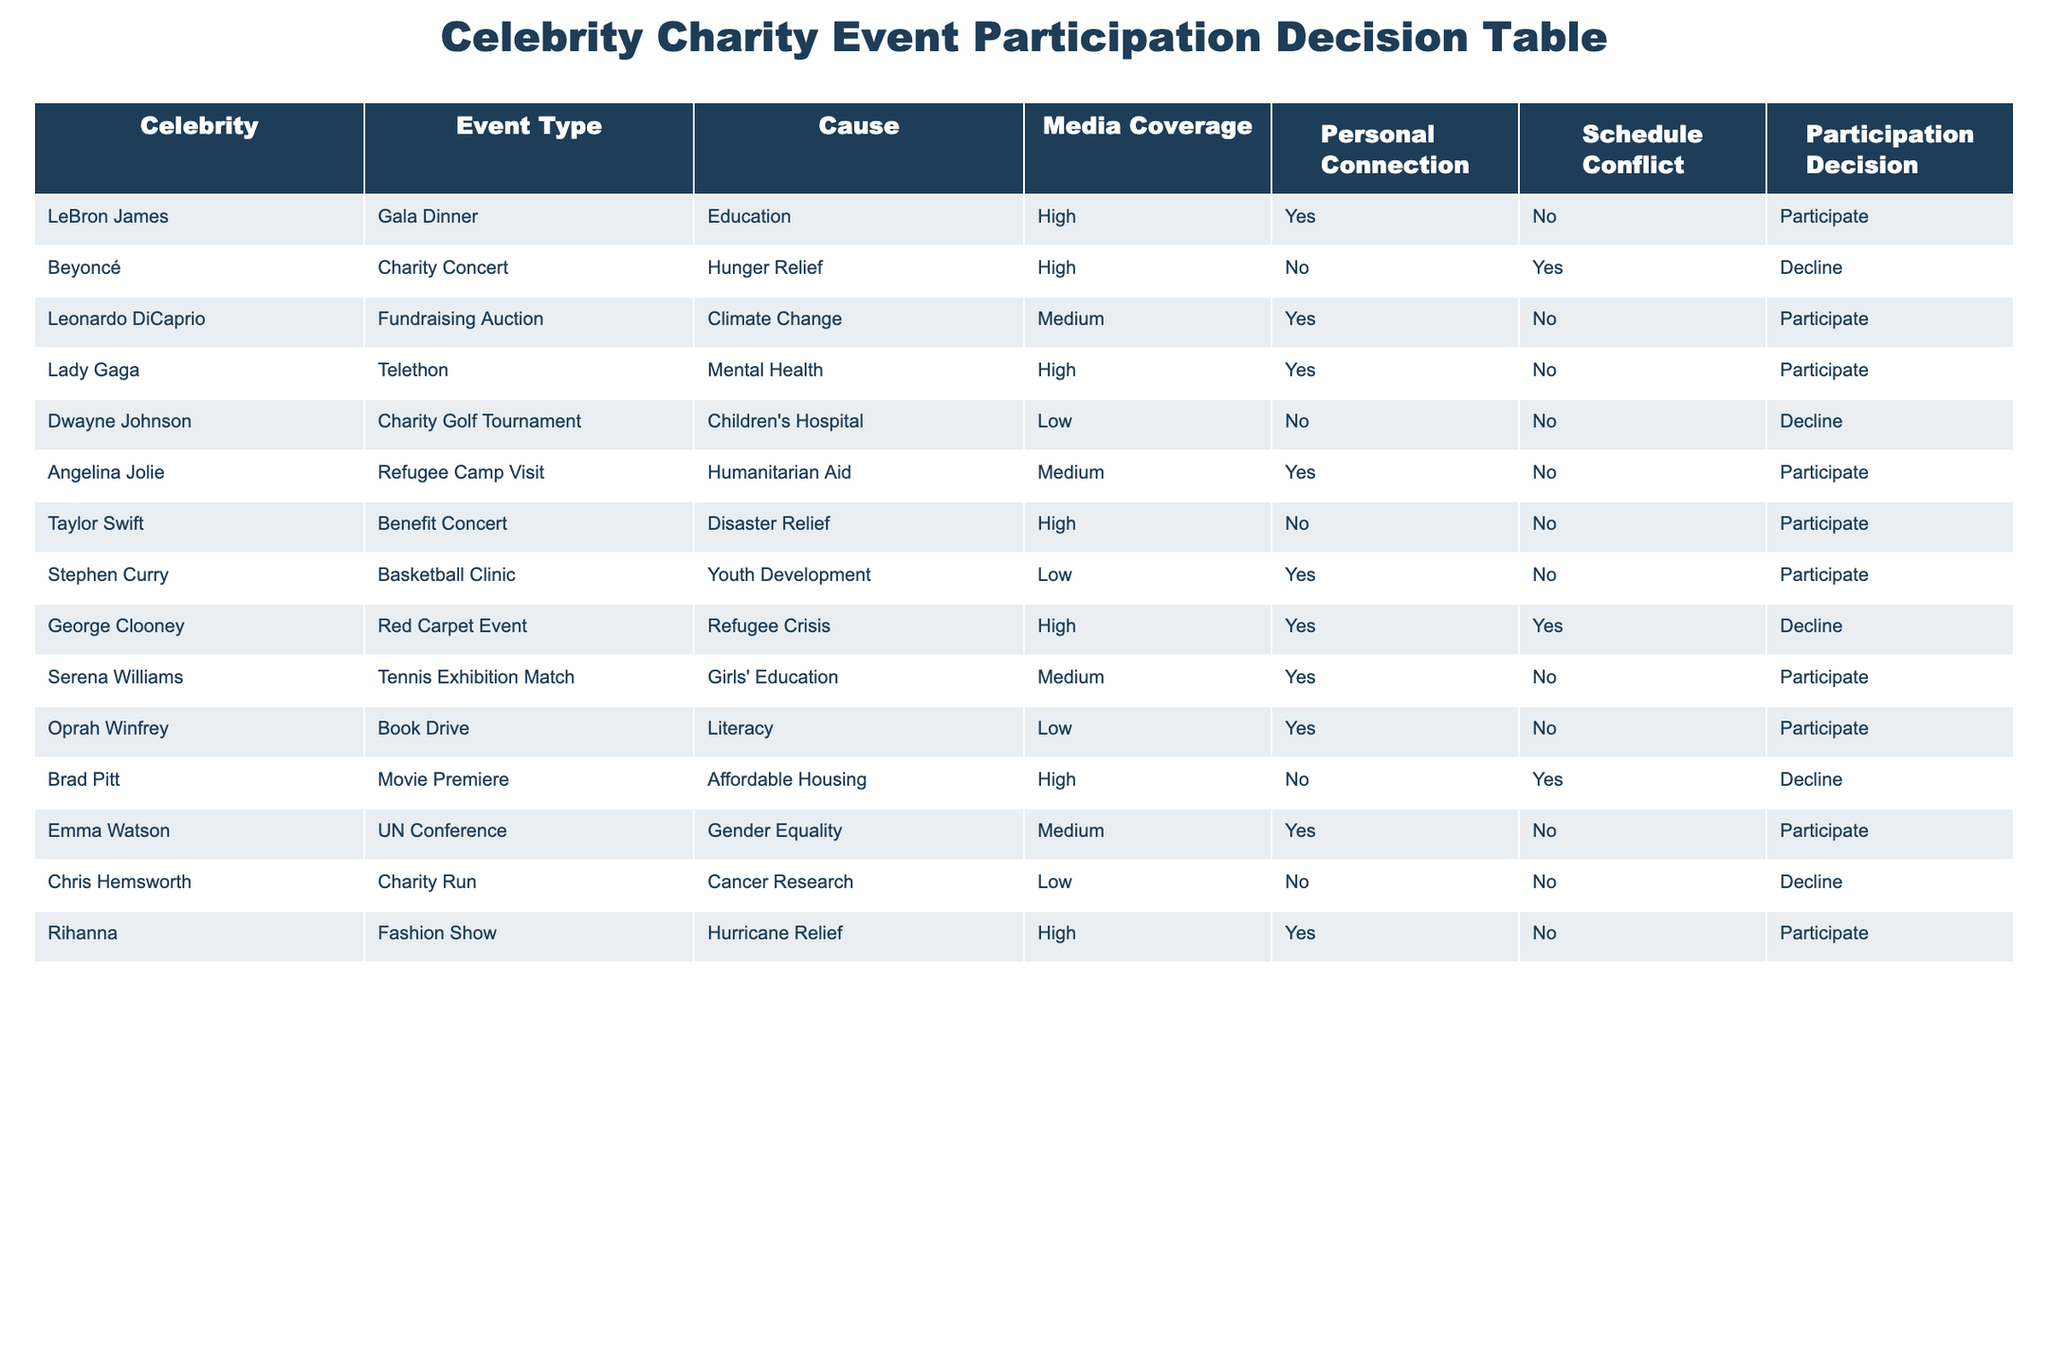What is the participation decision for Leonardo DiCaprio? In the table, we can locate the row for Leonardo DiCaprio, where his participation decision is stated clearly. Based on this information, his decision is to participate in the fundraising auction for climate change.
Answer: Participate How many celebrities declined to participate in an event? By scanning the table for the participation decision, I can count the rows where the decision is "Decline." There are four celebrities who declined to participate: Beyoncé, Dwayne Johnson, George Clooney, and Brad Pitt.
Answer: 4 Which celebrity has a personal connection to their cause but decided not to participate? I can look for rows where "Personal Connection" is marked as "Yes" and "Participation Decision" as "Decline." The only celebrity fitting this description is George Clooney, who has a personal connection to the refugee crisis but declined to participate in the red carpet event.
Answer: George Clooney What percentage of the celebrities in the table decided to participate in an event? First, I count the total number of celebrities listed, which is 15. Then I count how many decided to participate, which totals 9. To find the percentage, I divide 9 by 15 and multiply by 100: (9/15) * 100 = 60%. Therefore, 60% of the celebrities decided to participate in an event.
Answer: 60% Which event type had the most participants, according to the table? By evaluating the event types, I can see that several celebrities participated in different types of events. Counting each participation per event type: Gala Dinner, Fundraising Auction, Telethon, Benefit Concert, Basketball Clinic, Refugee Camp Visit, and others reveals that the most participation is in the Benefit Concert, with 1 participant (Taylor Swift). It appears there are multiple event types with 1 participant each, so no event type stands out as the most popular based on participation alone.
Answer: No clear most popular event type Did any celebrity decline participation due to a schedule conflict? To determine this, I check the "Schedule Conflict" column for entries with "Yes" in those who declined participation. Checking the data, the only celebrity in that situation is George Clooney, indicating that he had a schedule conflict which contributed to his decision to decline.
Answer: Yes What is the outcome for celebrities connected to education causes? I can look at the rows that specify "Education" under the "Cause" column. LeBron James and Serena Williams are the two celebrities connected to education causes. LeBron decided to participate while Serena also chose to participate. This means both have positive outcomes in terms of participation related to education.
Answer: Both participated How many celebrities participated with a high level of media coverage? I review the table for celebrities with "High" under "Media Coverage" and look for their participation decision. Upon examining the rows, I find that there are six celebrities who participated with high media coverage: LeBron James, Beyoncé, Lady Gaga, Taylor Swift, Rihanna, and Serena Williams. Among them, the ones who didn't decline (the focus is on participation) indicate there are 5 with high media coverage.
Answer: 5 